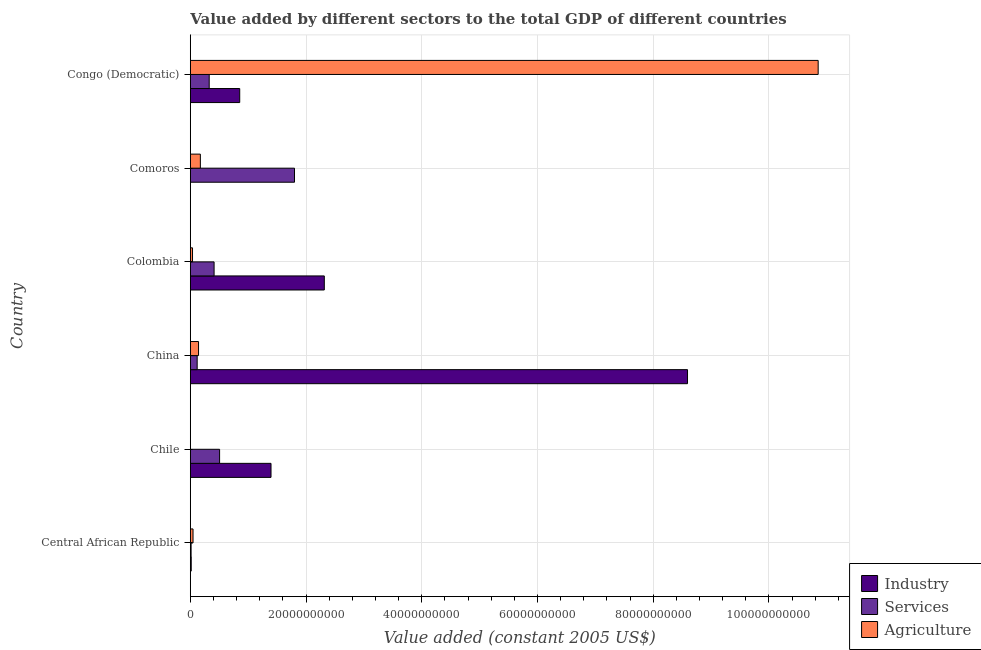How many different coloured bars are there?
Make the answer very short. 3. Are the number of bars on each tick of the Y-axis equal?
Make the answer very short. Yes. How many bars are there on the 1st tick from the top?
Ensure brevity in your answer.  3. What is the label of the 6th group of bars from the top?
Make the answer very short. Central African Republic. What is the value added by agricultural sector in China?
Give a very brief answer. 1.43e+09. Across all countries, what is the maximum value added by agricultural sector?
Keep it short and to the point. 1.09e+11. Across all countries, what is the minimum value added by agricultural sector?
Your answer should be very brief. 2.01e+07. In which country was the value added by agricultural sector maximum?
Keep it short and to the point. Congo (Democratic). In which country was the value added by services minimum?
Ensure brevity in your answer.  Central African Republic. What is the total value added by industrial sector in the graph?
Provide a succinct answer. 1.32e+11. What is the difference between the value added by services in Central African Republic and that in Congo (Democratic)?
Give a very brief answer. -3.13e+09. What is the difference between the value added by industrial sector in China and the value added by agricultural sector in Congo (Democratic)?
Provide a short and direct response. -2.26e+1. What is the average value added by services per country?
Offer a very short reply. 5.30e+09. What is the difference between the value added by agricultural sector and value added by industrial sector in Congo (Democratic)?
Make the answer very short. 1.00e+11. What is the ratio of the value added by services in Chile to that in Comoros?
Your answer should be compact. 0.28. Is the value added by agricultural sector in Colombia less than that in Congo (Democratic)?
Ensure brevity in your answer.  Yes. Is the difference between the value added by industrial sector in Chile and Congo (Democratic) greater than the difference between the value added by agricultural sector in Chile and Congo (Democratic)?
Offer a terse response. Yes. What is the difference between the highest and the second highest value added by agricultural sector?
Offer a terse response. 1.07e+11. What is the difference between the highest and the lowest value added by services?
Your response must be concise. 1.79e+1. Is the sum of the value added by agricultural sector in China and Comoros greater than the maximum value added by industrial sector across all countries?
Give a very brief answer. No. What does the 3rd bar from the top in Comoros represents?
Your response must be concise. Industry. What does the 2nd bar from the bottom in China represents?
Your answer should be very brief. Services. What is the difference between two consecutive major ticks on the X-axis?
Your answer should be very brief. 2.00e+1. Are the values on the major ticks of X-axis written in scientific E-notation?
Provide a short and direct response. No. Does the graph contain any zero values?
Your answer should be very brief. No. How many legend labels are there?
Your response must be concise. 3. How are the legend labels stacked?
Ensure brevity in your answer.  Vertical. What is the title of the graph?
Provide a succinct answer. Value added by different sectors to the total GDP of different countries. Does "Tertiary" appear as one of the legend labels in the graph?
Ensure brevity in your answer.  No. What is the label or title of the X-axis?
Provide a short and direct response. Value added (constant 2005 US$). What is the label or title of the Y-axis?
Keep it short and to the point. Country. What is the Value added (constant 2005 US$) in Industry in Central African Republic?
Give a very brief answer. 1.59e+08. What is the Value added (constant 2005 US$) in Services in Central African Republic?
Your answer should be compact. 1.38e+08. What is the Value added (constant 2005 US$) in Agriculture in Central African Republic?
Offer a terse response. 4.73e+08. What is the Value added (constant 2005 US$) in Industry in Chile?
Give a very brief answer. 1.39e+1. What is the Value added (constant 2005 US$) of Services in Chile?
Give a very brief answer. 5.06e+09. What is the Value added (constant 2005 US$) of Agriculture in Chile?
Your answer should be very brief. 2.01e+07. What is the Value added (constant 2005 US$) of Industry in China?
Ensure brevity in your answer.  8.59e+1. What is the Value added (constant 2005 US$) of Services in China?
Your answer should be compact. 1.19e+09. What is the Value added (constant 2005 US$) of Agriculture in China?
Offer a very short reply. 1.43e+09. What is the Value added (constant 2005 US$) of Industry in Colombia?
Make the answer very short. 2.32e+1. What is the Value added (constant 2005 US$) in Services in Colombia?
Provide a succinct answer. 4.11e+09. What is the Value added (constant 2005 US$) in Agriculture in Colombia?
Make the answer very short. 3.83e+08. What is the Value added (constant 2005 US$) in Industry in Comoros?
Keep it short and to the point. 3.44e+07. What is the Value added (constant 2005 US$) of Services in Comoros?
Provide a short and direct response. 1.80e+1. What is the Value added (constant 2005 US$) of Agriculture in Comoros?
Give a very brief answer. 1.74e+09. What is the Value added (constant 2005 US$) in Industry in Congo (Democratic)?
Give a very brief answer. 8.54e+09. What is the Value added (constant 2005 US$) of Services in Congo (Democratic)?
Your answer should be very brief. 3.27e+09. What is the Value added (constant 2005 US$) in Agriculture in Congo (Democratic)?
Give a very brief answer. 1.09e+11. Across all countries, what is the maximum Value added (constant 2005 US$) in Industry?
Provide a succinct answer. 8.59e+1. Across all countries, what is the maximum Value added (constant 2005 US$) of Services?
Give a very brief answer. 1.80e+1. Across all countries, what is the maximum Value added (constant 2005 US$) in Agriculture?
Your response must be concise. 1.09e+11. Across all countries, what is the minimum Value added (constant 2005 US$) of Industry?
Ensure brevity in your answer.  3.44e+07. Across all countries, what is the minimum Value added (constant 2005 US$) in Services?
Your answer should be compact. 1.38e+08. Across all countries, what is the minimum Value added (constant 2005 US$) of Agriculture?
Give a very brief answer. 2.01e+07. What is the total Value added (constant 2005 US$) in Industry in the graph?
Give a very brief answer. 1.32e+11. What is the total Value added (constant 2005 US$) of Services in the graph?
Your answer should be very brief. 3.18e+1. What is the total Value added (constant 2005 US$) of Agriculture in the graph?
Your answer should be very brief. 1.13e+11. What is the difference between the Value added (constant 2005 US$) in Industry in Central African Republic and that in Chile?
Make the answer very short. -1.38e+1. What is the difference between the Value added (constant 2005 US$) in Services in Central African Republic and that in Chile?
Provide a short and direct response. -4.93e+09. What is the difference between the Value added (constant 2005 US$) in Agriculture in Central African Republic and that in Chile?
Make the answer very short. 4.53e+08. What is the difference between the Value added (constant 2005 US$) of Industry in Central African Republic and that in China?
Your answer should be compact. -8.58e+1. What is the difference between the Value added (constant 2005 US$) in Services in Central African Republic and that in China?
Give a very brief answer. -1.05e+09. What is the difference between the Value added (constant 2005 US$) of Agriculture in Central African Republic and that in China?
Provide a succinct answer. -9.53e+08. What is the difference between the Value added (constant 2005 US$) of Industry in Central African Republic and that in Colombia?
Your answer should be very brief. -2.30e+1. What is the difference between the Value added (constant 2005 US$) of Services in Central African Republic and that in Colombia?
Your answer should be compact. -3.97e+09. What is the difference between the Value added (constant 2005 US$) of Agriculture in Central African Republic and that in Colombia?
Provide a succinct answer. 8.98e+07. What is the difference between the Value added (constant 2005 US$) in Industry in Central African Republic and that in Comoros?
Your answer should be compact. 1.24e+08. What is the difference between the Value added (constant 2005 US$) of Services in Central African Republic and that in Comoros?
Your answer should be compact. -1.79e+1. What is the difference between the Value added (constant 2005 US$) of Agriculture in Central African Republic and that in Comoros?
Ensure brevity in your answer.  -1.27e+09. What is the difference between the Value added (constant 2005 US$) of Industry in Central African Republic and that in Congo (Democratic)?
Offer a very short reply. -8.38e+09. What is the difference between the Value added (constant 2005 US$) of Services in Central African Republic and that in Congo (Democratic)?
Your response must be concise. -3.13e+09. What is the difference between the Value added (constant 2005 US$) of Agriculture in Central African Republic and that in Congo (Democratic)?
Ensure brevity in your answer.  -1.08e+11. What is the difference between the Value added (constant 2005 US$) in Industry in Chile and that in China?
Make the answer very short. -7.20e+1. What is the difference between the Value added (constant 2005 US$) in Services in Chile and that in China?
Offer a terse response. 3.87e+09. What is the difference between the Value added (constant 2005 US$) in Agriculture in Chile and that in China?
Offer a terse response. -1.41e+09. What is the difference between the Value added (constant 2005 US$) in Industry in Chile and that in Colombia?
Make the answer very short. -9.21e+09. What is the difference between the Value added (constant 2005 US$) of Services in Chile and that in Colombia?
Provide a succinct answer. 9.52e+08. What is the difference between the Value added (constant 2005 US$) in Agriculture in Chile and that in Colombia?
Keep it short and to the point. -3.63e+08. What is the difference between the Value added (constant 2005 US$) in Industry in Chile and that in Comoros?
Give a very brief answer. 1.39e+1. What is the difference between the Value added (constant 2005 US$) of Services in Chile and that in Comoros?
Your response must be concise. -1.29e+1. What is the difference between the Value added (constant 2005 US$) in Agriculture in Chile and that in Comoros?
Your answer should be compact. -1.72e+09. What is the difference between the Value added (constant 2005 US$) of Industry in Chile and that in Congo (Democratic)?
Your answer should be compact. 5.41e+09. What is the difference between the Value added (constant 2005 US$) of Services in Chile and that in Congo (Democratic)?
Offer a terse response. 1.80e+09. What is the difference between the Value added (constant 2005 US$) in Agriculture in Chile and that in Congo (Democratic)?
Your answer should be compact. -1.08e+11. What is the difference between the Value added (constant 2005 US$) of Industry in China and that in Colombia?
Offer a very short reply. 6.28e+1. What is the difference between the Value added (constant 2005 US$) in Services in China and that in Colombia?
Your response must be concise. -2.92e+09. What is the difference between the Value added (constant 2005 US$) of Agriculture in China and that in Colombia?
Make the answer very short. 1.04e+09. What is the difference between the Value added (constant 2005 US$) in Industry in China and that in Comoros?
Provide a succinct answer. 8.59e+1. What is the difference between the Value added (constant 2005 US$) of Services in China and that in Comoros?
Your answer should be compact. -1.68e+1. What is the difference between the Value added (constant 2005 US$) in Agriculture in China and that in Comoros?
Offer a terse response. -3.13e+08. What is the difference between the Value added (constant 2005 US$) in Industry in China and that in Congo (Democratic)?
Your answer should be compact. 7.74e+1. What is the difference between the Value added (constant 2005 US$) of Services in China and that in Congo (Democratic)?
Ensure brevity in your answer.  -2.08e+09. What is the difference between the Value added (constant 2005 US$) in Agriculture in China and that in Congo (Democratic)?
Your response must be concise. -1.07e+11. What is the difference between the Value added (constant 2005 US$) of Industry in Colombia and that in Comoros?
Your answer should be compact. 2.31e+1. What is the difference between the Value added (constant 2005 US$) in Services in Colombia and that in Comoros?
Offer a very short reply. -1.39e+1. What is the difference between the Value added (constant 2005 US$) of Agriculture in Colombia and that in Comoros?
Give a very brief answer. -1.36e+09. What is the difference between the Value added (constant 2005 US$) of Industry in Colombia and that in Congo (Democratic)?
Keep it short and to the point. 1.46e+1. What is the difference between the Value added (constant 2005 US$) of Services in Colombia and that in Congo (Democratic)?
Provide a short and direct response. 8.44e+08. What is the difference between the Value added (constant 2005 US$) in Agriculture in Colombia and that in Congo (Democratic)?
Provide a short and direct response. -1.08e+11. What is the difference between the Value added (constant 2005 US$) of Industry in Comoros and that in Congo (Democratic)?
Offer a very short reply. -8.51e+09. What is the difference between the Value added (constant 2005 US$) in Services in Comoros and that in Congo (Democratic)?
Keep it short and to the point. 1.47e+1. What is the difference between the Value added (constant 2005 US$) of Agriculture in Comoros and that in Congo (Democratic)?
Ensure brevity in your answer.  -1.07e+11. What is the difference between the Value added (constant 2005 US$) in Industry in Central African Republic and the Value added (constant 2005 US$) in Services in Chile?
Your answer should be very brief. -4.91e+09. What is the difference between the Value added (constant 2005 US$) of Industry in Central African Republic and the Value added (constant 2005 US$) of Agriculture in Chile?
Provide a succinct answer. 1.39e+08. What is the difference between the Value added (constant 2005 US$) in Services in Central African Republic and the Value added (constant 2005 US$) in Agriculture in Chile?
Keep it short and to the point. 1.18e+08. What is the difference between the Value added (constant 2005 US$) of Industry in Central African Republic and the Value added (constant 2005 US$) of Services in China?
Keep it short and to the point. -1.03e+09. What is the difference between the Value added (constant 2005 US$) of Industry in Central African Republic and the Value added (constant 2005 US$) of Agriculture in China?
Ensure brevity in your answer.  -1.27e+09. What is the difference between the Value added (constant 2005 US$) in Services in Central African Republic and the Value added (constant 2005 US$) in Agriculture in China?
Offer a terse response. -1.29e+09. What is the difference between the Value added (constant 2005 US$) in Industry in Central African Republic and the Value added (constant 2005 US$) in Services in Colombia?
Offer a terse response. -3.95e+09. What is the difference between the Value added (constant 2005 US$) in Industry in Central African Republic and the Value added (constant 2005 US$) in Agriculture in Colombia?
Give a very brief answer. -2.24e+08. What is the difference between the Value added (constant 2005 US$) in Services in Central African Republic and the Value added (constant 2005 US$) in Agriculture in Colombia?
Your answer should be very brief. -2.45e+08. What is the difference between the Value added (constant 2005 US$) in Industry in Central African Republic and the Value added (constant 2005 US$) in Services in Comoros?
Your answer should be very brief. -1.79e+1. What is the difference between the Value added (constant 2005 US$) in Industry in Central African Republic and the Value added (constant 2005 US$) in Agriculture in Comoros?
Keep it short and to the point. -1.58e+09. What is the difference between the Value added (constant 2005 US$) in Services in Central African Republic and the Value added (constant 2005 US$) in Agriculture in Comoros?
Offer a terse response. -1.60e+09. What is the difference between the Value added (constant 2005 US$) of Industry in Central African Republic and the Value added (constant 2005 US$) of Services in Congo (Democratic)?
Make the answer very short. -3.11e+09. What is the difference between the Value added (constant 2005 US$) of Industry in Central African Republic and the Value added (constant 2005 US$) of Agriculture in Congo (Democratic)?
Give a very brief answer. -1.08e+11. What is the difference between the Value added (constant 2005 US$) in Services in Central African Republic and the Value added (constant 2005 US$) in Agriculture in Congo (Democratic)?
Ensure brevity in your answer.  -1.08e+11. What is the difference between the Value added (constant 2005 US$) in Industry in Chile and the Value added (constant 2005 US$) in Services in China?
Offer a terse response. 1.28e+1. What is the difference between the Value added (constant 2005 US$) in Industry in Chile and the Value added (constant 2005 US$) in Agriculture in China?
Offer a terse response. 1.25e+1. What is the difference between the Value added (constant 2005 US$) in Services in Chile and the Value added (constant 2005 US$) in Agriculture in China?
Ensure brevity in your answer.  3.64e+09. What is the difference between the Value added (constant 2005 US$) of Industry in Chile and the Value added (constant 2005 US$) of Services in Colombia?
Your response must be concise. 9.84e+09. What is the difference between the Value added (constant 2005 US$) of Industry in Chile and the Value added (constant 2005 US$) of Agriculture in Colombia?
Offer a very short reply. 1.36e+1. What is the difference between the Value added (constant 2005 US$) in Services in Chile and the Value added (constant 2005 US$) in Agriculture in Colombia?
Offer a very short reply. 4.68e+09. What is the difference between the Value added (constant 2005 US$) of Industry in Chile and the Value added (constant 2005 US$) of Services in Comoros?
Offer a terse response. -4.06e+09. What is the difference between the Value added (constant 2005 US$) in Industry in Chile and the Value added (constant 2005 US$) in Agriculture in Comoros?
Your answer should be compact. 1.22e+1. What is the difference between the Value added (constant 2005 US$) in Services in Chile and the Value added (constant 2005 US$) in Agriculture in Comoros?
Offer a very short reply. 3.32e+09. What is the difference between the Value added (constant 2005 US$) in Industry in Chile and the Value added (constant 2005 US$) in Services in Congo (Democratic)?
Offer a very short reply. 1.07e+1. What is the difference between the Value added (constant 2005 US$) of Industry in Chile and the Value added (constant 2005 US$) of Agriculture in Congo (Democratic)?
Make the answer very short. -9.46e+1. What is the difference between the Value added (constant 2005 US$) in Services in Chile and the Value added (constant 2005 US$) in Agriculture in Congo (Democratic)?
Give a very brief answer. -1.03e+11. What is the difference between the Value added (constant 2005 US$) of Industry in China and the Value added (constant 2005 US$) of Services in Colombia?
Ensure brevity in your answer.  8.18e+1. What is the difference between the Value added (constant 2005 US$) in Industry in China and the Value added (constant 2005 US$) in Agriculture in Colombia?
Offer a terse response. 8.55e+1. What is the difference between the Value added (constant 2005 US$) in Services in China and the Value added (constant 2005 US$) in Agriculture in Colombia?
Your answer should be very brief. 8.06e+08. What is the difference between the Value added (constant 2005 US$) of Industry in China and the Value added (constant 2005 US$) of Services in Comoros?
Offer a terse response. 6.79e+1. What is the difference between the Value added (constant 2005 US$) in Industry in China and the Value added (constant 2005 US$) in Agriculture in Comoros?
Ensure brevity in your answer.  8.42e+1. What is the difference between the Value added (constant 2005 US$) in Services in China and the Value added (constant 2005 US$) in Agriculture in Comoros?
Keep it short and to the point. -5.50e+08. What is the difference between the Value added (constant 2005 US$) in Industry in China and the Value added (constant 2005 US$) in Services in Congo (Democratic)?
Make the answer very short. 8.27e+1. What is the difference between the Value added (constant 2005 US$) in Industry in China and the Value added (constant 2005 US$) in Agriculture in Congo (Democratic)?
Provide a succinct answer. -2.26e+1. What is the difference between the Value added (constant 2005 US$) in Services in China and the Value added (constant 2005 US$) in Agriculture in Congo (Democratic)?
Offer a very short reply. -1.07e+11. What is the difference between the Value added (constant 2005 US$) in Industry in Colombia and the Value added (constant 2005 US$) in Services in Comoros?
Provide a succinct answer. 5.15e+09. What is the difference between the Value added (constant 2005 US$) in Industry in Colombia and the Value added (constant 2005 US$) in Agriculture in Comoros?
Ensure brevity in your answer.  2.14e+1. What is the difference between the Value added (constant 2005 US$) in Services in Colombia and the Value added (constant 2005 US$) in Agriculture in Comoros?
Your answer should be compact. 2.37e+09. What is the difference between the Value added (constant 2005 US$) of Industry in Colombia and the Value added (constant 2005 US$) of Services in Congo (Democratic)?
Your answer should be compact. 1.99e+1. What is the difference between the Value added (constant 2005 US$) in Industry in Colombia and the Value added (constant 2005 US$) in Agriculture in Congo (Democratic)?
Ensure brevity in your answer.  -8.53e+1. What is the difference between the Value added (constant 2005 US$) of Services in Colombia and the Value added (constant 2005 US$) of Agriculture in Congo (Democratic)?
Offer a terse response. -1.04e+11. What is the difference between the Value added (constant 2005 US$) of Industry in Comoros and the Value added (constant 2005 US$) of Services in Congo (Democratic)?
Offer a very short reply. -3.23e+09. What is the difference between the Value added (constant 2005 US$) in Industry in Comoros and the Value added (constant 2005 US$) in Agriculture in Congo (Democratic)?
Your response must be concise. -1.08e+11. What is the difference between the Value added (constant 2005 US$) of Services in Comoros and the Value added (constant 2005 US$) of Agriculture in Congo (Democratic)?
Offer a terse response. -9.05e+1. What is the average Value added (constant 2005 US$) of Industry per country?
Ensure brevity in your answer.  2.20e+1. What is the average Value added (constant 2005 US$) in Services per country?
Your answer should be compact. 5.30e+09. What is the average Value added (constant 2005 US$) in Agriculture per country?
Offer a terse response. 1.88e+1. What is the difference between the Value added (constant 2005 US$) in Industry and Value added (constant 2005 US$) in Services in Central African Republic?
Provide a succinct answer. 2.12e+07. What is the difference between the Value added (constant 2005 US$) in Industry and Value added (constant 2005 US$) in Agriculture in Central African Republic?
Offer a very short reply. -3.14e+08. What is the difference between the Value added (constant 2005 US$) of Services and Value added (constant 2005 US$) of Agriculture in Central African Republic?
Ensure brevity in your answer.  -3.35e+08. What is the difference between the Value added (constant 2005 US$) of Industry and Value added (constant 2005 US$) of Services in Chile?
Your response must be concise. 8.88e+09. What is the difference between the Value added (constant 2005 US$) in Industry and Value added (constant 2005 US$) in Agriculture in Chile?
Provide a short and direct response. 1.39e+1. What is the difference between the Value added (constant 2005 US$) of Services and Value added (constant 2005 US$) of Agriculture in Chile?
Keep it short and to the point. 5.04e+09. What is the difference between the Value added (constant 2005 US$) in Industry and Value added (constant 2005 US$) in Services in China?
Your answer should be very brief. 8.47e+1. What is the difference between the Value added (constant 2005 US$) in Industry and Value added (constant 2005 US$) in Agriculture in China?
Your response must be concise. 8.45e+1. What is the difference between the Value added (constant 2005 US$) of Services and Value added (constant 2005 US$) of Agriculture in China?
Give a very brief answer. -2.37e+08. What is the difference between the Value added (constant 2005 US$) of Industry and Value added (constant 2005 US$) of Services in Colombia?
Ensure brevity in your answer.  1.90e+1. What is the difference between the Value added (constant 2005 US$) of Industry and Value added (constant 2005 US$) of Agriculture in Colombia?
Provide a succinct answer. 2.28e+1. What is the difference between the Value added (constant 2005 US$) of Services and Value added (constant 2005 US$) of Agriculture in Colombia?
Your answer should be very brief. 3.73e+09. What is the difference between the Value added (constant 2005 US$) in Industry and Value added (constant 2005 US$) in Services in Comoros?
Your answer should be very brief. -1.80e+1. What is the difference between the Value added (constant 2005 US$) in Industry and Value added (constant 2005 US$) in Agriculture in Comoros?
Give a very brief answer. -1.71e+09. What is the difference between the Value added (constant 2005 US$) in Services and Value added (constant 2005 US$) in Agriculture in Comoros?
Your answer should be compact. 1.63e+1. What is the difference between the Value added (constant 2005 US$) in Industry and Value added (constant 2005 US$) in Services in Congo (Democratic)?
Provide a short and direct response. 5.27e+09. What is the difference between the Value added (constant 2005 US$) in Industry and Value added (constant 2005 US$) in Agriculture in Congo (Democratic)?
Give a very brief answer. -1.00e+11. What is the difference between the Value added (constant 2005 US$) of Services and Value added (constant 2005 US$) of Agriculture in Congo (Democratic)?
Your answer should be compact. -1.05e+11. What is the ratio of the Value added (constant 2005 US$) of Industry in Central African Republic to that in Chile?
Keep it short and to the point. 0.01. What is the ratio of the Value added (constant 2005 US$) of Services in Central African Republic to that in Chile?
Your answer should be compact. 0.03. What is the ratio of the Value added (constant 2005 US$) of Agriculture in Central African Republic to that in Chile?
Your response must be concise. 23.53. What is the ratio of the Value added (constant 2005 US$) in Industry in Central African Republic to that in China?
Your answer should be very brief. 0. What is the ratio of the Value added (constant 2005 US$) in Services in Central African Republic to that in China?
Your answer should be compact. 0.12. What is the ratio of the Value added (constant 2005 US$) in Agriculture in Central African Republic to that in China?
Keep it short and to the point. 0.33. What is the ratio of the Value added (constant 2005 US$) of Industry in Central African Republic to that in Colombia?
Make the answer very short. 0.01. What is the ratio of the Value added (constant 2005 US$) in Services in Central African Republic to that in Colombia?
Give a very brief answer. 0.03. What is the ratio of the Value added (constant 2005 US$) of Agriculture in Central African Republic to that in Colombia?
Your answer should be compact. 1.23. What is the ratio of the Value added (constant 2005 US$) in Industry in Central African Republic to that in Comoros?
Ensure brevity in your answer.  4.61. What is the ratio of the Value added (constant 2005 US$) in Services in Central African Republic to that in Comoros?
Keep it short and to the point. 0.01. What is the ratio of the Value added (constant 2005 US$) of Agriculture in Central African Republic to that in Comoros?
Give a very brief answer. 0.27. What is the ratio of the Value added (constant 2005 US$) of Industry in Central African Republic to that in Congo (Democratic)?
Keep it short and to the point. 0.02. What is the ratio of the Value added (constant 2005 US$) in Services in Central African Republic to that in Congo (Democratic)?
Provide a short and direct response. 0.04. What is the ratio of the Value added (constant 2005 US$) of Agriculture in Central African Republic to that in Congo (Democratic)?
Your answer should be very brief. 0. What is the ratio of the Value added (constant 2005 US$) of Industry in Chile to that in China?
Offer a very short reply. 0.16. What is the ratio of the Value added (constant 2005 US$) in Services in Chile to that in China?
Give a very brief answer. 4.26. What is the ratio of the Value added (constant 2005 US$) of Agriculture in Chile to that in China?
Your answer should be compact. 0.01. What is the ratio of the Value added (constant 2005 US$) in Industry in Chile to that in Colombia?
Keep it short and to the point. 0.6. What is the ratio of the Value added (constant 2005 US$) in Services in Chile to that in Colombia?
Offer a very short reply. 1.23. What is the ratio of the Value added (constant 2005 US$) in Agriculture in Chile to that in Colombia?
Ensure brevity in your answer.  0.05. What is the ratio of the Value added (constant 2005 US$) of Industry in Chile to that in Comoros?
Ensure brevity in your answer.  404.94. What is the ratio of the Value added (constant 2005 US$) of Services in Chile to that in Comoros?
Offer a very short reply. 0.28. What is the ratio of the Value added (constant 2005 US$) of Agriculture in Chile to that in Comoros?
Your answer should be compact. 0.01. What is the ratio of the Value added (constant 2005 US$) in Industry in Chile to that in Congo (Democratic)?
Offer a terse response. 1.63. What is the ratio of the Value added (constant 2005 US$) of Services in Chile to that in Congo (Democratic)?
Offer a very short reply. 1.55. What is the ratio of the Value added (constant 2005 US$) in Agriculture in Chile to that in Congo (Democratic)?
Keep it short and to the point. 0. What is the ratio of the Value added (constant 2005 US$) in Industry in China to that in Colombia?
Your answer should be very brief. 3.71. What is the ratio of the Value added (constant 2005 US$) of Services in China to that in Colombia?
Your answer should be very brief. 0.29. What is the ratio of the Value added (constant 2005 US$) in Agriculture in China to that in Colombia?
Give a very brief answer. 3.72. What is the ratio of the Value added (constant 2005 US$) of Industry in China to that in Comoros?
Provide a short and direct response. 2494.44. What is the ratio of the Value added (constant 2005 US$) of Services in China to that in Comoros?
Your answer should be compact. 0.07. What is the ratio of the Value added (constant 2005 US$) of Agriculture in China to that in Comoros?
Your answer should be compact. 0.82. What is the ratio of the Value added (constant 2005 US$) in Industry in China to that in Congo (Democratic)?
Offer a terse response. 10.06. What is the ratio of the Value added (constant 2005 US$) in Services in China to that in Congo (Democratic)?
Your answer should be compact. 0.36. What is the ratio of the Value added (constant 2005 US$) of Agriculture in China to that in Congo (Democratic)?
Offer a very short reply. 0.01. What is the ratio of the Value added (constant 2005 US$) of Industry in Colombia to that in Comoros?
Your answer should be compact. 672.35. What is the ratio of the Value added (constant 2005 US$) in Services in Colombia to that in Comoros?
Offer a very short reply. 0.23. What is the ratio of the Value added (constant 2005 US$) in Agriculture in Colombia to that in Comoros?
Offer a terse response. 0.22. What is the ratio of the Value added (constant 2005 US$) of Industry in Colombia to that in Congo (Democratic)?
Provide a short and direct response. 2.71. What is the ratio of the Value added (constant 2005 US$) of Services in Colombia to that in Congo (Democratic)?
Offer a very short reply. 1.26. What is the ratio of the Value added (constant 2005 US$) in Agriculture in Colombia to that in Congo (Democratic)?
Make the answer very short. 0. What is the ratio of the Value added (constant 2005 US$) of Industry in Comoros to that in Congo (Democratic)?
Give a very brief answer. 0. What is the ratio of the Value added (constant 2005 US$) of Services in Comoros to that in Congo (Democratic)?
Give a very brief answer. 5.51. What is the ratio of the Value added (constant 2005 US$) in Agriculture in Comoros to that in Congo (Democratic)?
Make the answer very short. 0.02. What is the difference between the highest and the second highest Value added (constant 2005 US$) of Industry?
Your answer should be compact. 6.28e+1. What is the difference between the highest and the second highest Value added (constant 2005 US$) of Services?
Ensure brevity in your answer.  1.29e+1. What is the difference between the highest and the second highest Value added (constant 2005 US$) of Agriculture?
Your answer should be very brief. 1.07e+11. What is the difference between the highest and the lowest Value added (constant 2005 US$) in Industry?
Your answer should be compact. 8.59e+1. What is the difference between the highest and the lowest Value added (constant 2005 US$) in Services?
Offer a very short reply. 1.79e+1. What is the difference between the highest and the lowest Value added (constant 2005 US$) in Agriculture?
Your answer should be very brief. 1.08e+11. 